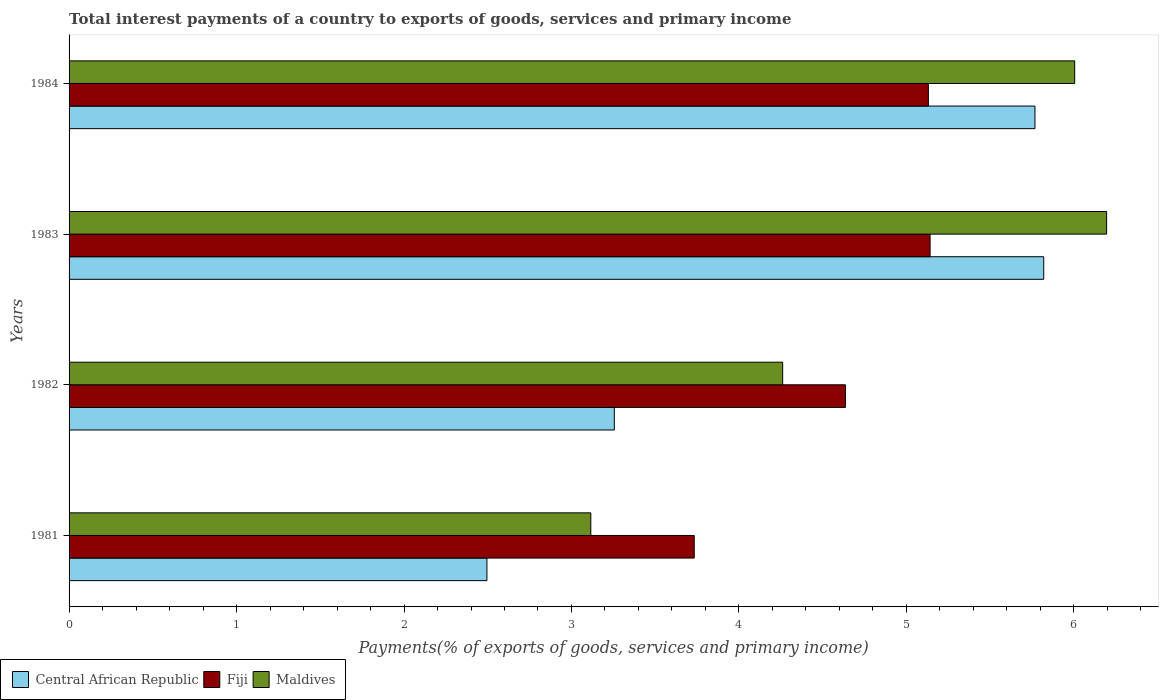How many different coloured bars are there?
Make the answer very short. 3. Are the number of bars per tick equal to the number of legend labels?
Give a very brief answer. Yes. How many bars are there on the 2nd tick from the bottom?
Your answer should be compact. 3. What is the label of the 1st group of bars from the top?
Your response must be concise. 1984. What is the total interest payments in Central African Republic in 1984?
Offer a terse response. 5.77. Across all years, what is the maximum total interest payments in Fiji?
Your answer should be very brief. 5.14. Across all years, what is the minimum total interest payments in Maldives?
Offer a very short reply. 3.12. In which year was the total interest payments in Fiji maximum?
Your response must be concise. 1983. In which year was the total interest payments in Maldives minimum?
Your answer should be compact. 1981. What is the total total interest payments in Central African Republic in the graph?
Provide a succinct answer. 17.34. What is the difference between the total interest payments in Central African Republic in 1983 and that in 1984?
Offer a terse response. 0.05. What is the difference between the total interest payments in Maldives in 1981 and the total interest payments in Fiji in 1983?
Provide a short and direct response. -2.03. What is the average total interest payments in Maldives per year?
Your answer should be compact. 4.89. In the year 1983, what is the difference between the total interest payments in Maldives and total interest payments in Fiji?
Your response must be concise. 1.05. What is the ratio of the total interest payments in Central African Republic in 1981 to that in 1982?
Offer a terse response. 0.77. Is the total interest payments in Central African Republic in 1983 less than that in 1984?
Your answer should be compact. No. What is the difference between the highest and the second highest total interest payments in Central African Republic?
Your response must be concise. 0.05. What is the difference between the highest and the lowest total interest payments in Central African Republic?
Provide a short and direct response. 3.32. In how many years, is the total interest payments in Maldives greater than the average total interest payments in Maldives taken over all years?
Your response must be concise. 2. Is the sum of the total interest payments in Maldives in 1981 and 1983 greater than the maximum total interest payments in Central African Republic across all years?
Your response must be concise. Yes. What does the 2nd bar from the top in 1984 represents?
Keep it short and to the point. Fiji. What does the 3rd bar from the bottom in 1981 represents?
Ensure brevity in your answer.  Maldives. Is it the case that in every year, the sum of the total interest payments in Central African Republic and total interest payments in Fiji is greater than the total interest payments in Maldives?
Your answer should be very brief. Yes. Does the graph contain grids?
Keep it short and to the point. No. Where does the legend appear in the graph?
Ensure brevity in your answer.  Bottom left. How many legend labels are there?
Your response must be concise. 3. What is the title of the graph?
Make the answer very short. Total interest payments of a country to exports of goods, services and primary income. What is the label or title of the X-axis?
Offer a terse response. Payments(% of exports of goods, services and primary income). What is the label or title of the Y-axis?
Provide a short and direct response. Years. What is the Payments(% of exports of goods, services and primary income) of Central African Republic in 1981?
Offer a very short reply. 2.5. What is the Payments(% of exports of goods, services and primary income) in Fiji in 1981?
Your answer should be compact. 3.73. What is the Payments(% of exports of goods, services and primary income) of Maldives in 1981?
Make the answer very short. 3.12. What is the Payments(% of exports of goods, services and primary income) of Central African Republic in 1982?
Your response must be concise. 3.26. What is the Payments(% of exports of goods, services and primary income) of Fiji in 1982?
Your answer should be compact. 4.64. What is the Payments(% of exports of goods, services and primary income) in Maldives in 1982?
Give a very brief answer. 4.26. What is the Payments(% of exports of goods, services and primary income) of Central African Republic in 1983?
Offer a terse response. 5.82. What is the Payments(% of exports of goods, services and primary income) of Fiji in 1983?
Offer a terse response. 5.14. What is the Payments(% of exports of goods, services and primary income) in Maldives in 1983?
Give a very brief answer. 6.2. What is the Payments(% of exports of goods, services and primary income) of Central African Republic in 1984?
Provide a succinct answer. 5.77. What is the Payments(% of exports of goods, services and primary income) of Fiji in 1984?
Ensure brevity in your answer.  5.13. What is the Payments(% of exports of goods, services and primary income) in Maldives in 1984?
Offer a terse response. 6. Across all years, what is the maximum Payments(% of exports of goods, services and primary income) of Central African Republic?
Provide a succinct answer. 5.82. Across all years, what is the maximum Payments(% of exports of goods, services and primary income) of Fiji?
Your answer should be compact. 5.14. Across all years, what is the maximum Payments(% of exports of goods, services and primary income) of Maldives?
Provide a succinct answer. 6.2. Across all years, what is the minimum Payments(% of exports of goods, services and primary income) in Central African Republic?
Your response must be concise. 2.5. Across all years, what is the minimum Payments(% of exports of goods, services and primary income) in Fiji?
Make the answer very short. 3.73. Across all years, what is the minimum Payments(% of exports of goods, services and primary income) of Maldives?
Make the answer very short. 3.12. What is the total Payments(% of exports of goods, services and primary income) of Central African Republic in the graph?
Ensure brevity in your answer.  17.34. What is the total Payments(% of exports of goods, services and primary income) of Fiji in the graph?
Your response must be concise. 18.64. What is the total Payments(% of exports of goods, services and primary income) of Maldives in the graph?
Offer a very short reply. 19.58. What is the difference between the Payments(% of exports of goods, services and primary income) in Central African Republic in 1981 and that in 1982?
Your response must be concise. -0.76. What is the difference between the Payments(% of exports of goods, services and primary income) in Fiji in 1981 and that in 1982?
Make the answer very short. -0.9. What is the difference between the Payments(% of exports of goods, services and primary income) in Maldives in 1981 and that in 1982?
Provide a short and direct response. -1.15. What is the difference between the Payments(% of exports of goods, services and primary income) in Central African Republic in 1981 and that in 1983?
Provide a short and direct response. -3.32. What is the difference between the Payments(% of exports of goods, services and primary income) in Fiji in 1981 and that in 1983?
Your response must be concise. -1.41. What is the difference between the Payments(% of exports of goods, services and primary income) of Maldives in 1981 and that in 1983?
Provide a short and direct response. -3.08. What is the difference between the Payments(% of exports of goods, services and primary income) in Central African Republic in 1981 and that in 1984?
Provide a succinct answer. -3.27. What is the difference between the Payments(% of exports of goods, services and primary income) in Fiji in 1981 and that in 1984?
Offer a very short reply. -1.4. What is the difference between the Payments(% of exports of goods, services and primary income) of Maldives in 1981 and that in 1984?
Your response must be concise. -2.89. What is the difference between the Payments(% of exports of goods, services and primary income) of Central African Republic in 1982 and that in 1983?
Your answer should be very brief. -2.56. What is the difference between the Payments(% of exports of goods, services and primary income) in Fiji in 1982 and that in 1983?
Give a very brief answer. -0.51. What is the difference between the Payments(% of exports of goods, services and primary income) of Maldives in 1982 and that in 1983?
Give a very brief answer. -1.93. What is the difference between the Payments(% of exports of goods, services and primary income) of Central African Republic in 1982 and that in 1984?
Your response must be concise. -2.51. What is the difference between the Payments(% of exports of goods, services and primary income) of Fiji in 1982 and that in 1984?
Ensure brevity in your answer.  -0.5. What is the difference between the Payments(% of exports of goods, services and primary income) of Maldives in 1982 and that in 1984?
Ensure brevity in your answer.  -1.74. What is the difference between the Payments(% of exports of goods, services and primary income) of Central African Republic in 1983 and that in 1984?
Ensure brevity in your answer.  0.05. What is the difference between the Payments(% of exports of goods, services and primary income) in Fiji in 1983 and that in 1984?
Your answer should be very brief. 0.01. What is the difference between the Payments(% of exports of goods, services and primary income) in Maldives in 1983 and that in 1984?
Offer a terse response. 0.19. What is the difference between the Payments(% of exports of goods, services and primary income) of Central African Republic in 1981 and the Payments(% of exports of goods, services and primary income) of Fiji in 1982?
Make the answer very short. -2.14. What is the difference between the Payments(% of exports of goods, services and primary income) of Central African Republic in 1981 and the Payments(% of exports of goods, services and primary income) of Maldives in 1982?
Provide a succinct answer. -1.77. What is the difference between the Payments(% of exports of goods, services and primary income) of Fiji in 1981 and the Payments(% of exports of goods, services and primary income) of Maldives in 1982?
Ensure brevity in your answer.  -0.53. What is the difference between the Payments(% of exports of goods, services and primary income) of Central African Republic in 1981 and the Payments(% of exports of goods, services and primary income) of Fiji in 1983?
Keep it short and to the point. -2.65. What is the difference between the Payments(% of exports of goods, services and primary income) of Central African Republic in 1981 and the Payments(% of exports of goods, services and primary income) of Maldives in 1983?
Offer a very short reply. -3.7. What is the difference between the Payments(% of exports of goods, services and primary income) in Fiji in 1981 and the Payments(% of exports of goods, services and primary income) in Maldives in 1983?
Give a very brief answer. -2.46. What is the difference between the Payments(% of exports of goods, services and primary income) of Central African Republic in 1981 and the Payments(% of exports of goods, services and primary income) of Fiji in 1984?
Offer a very short reply. -2.64. What is the difference between the Payments(% of exports of goods, services and primary income) of Central African Republic in 1981 and the Payments(% of exports of goods, services and primary income) of Maldives in 1984?
Your answer should be compact. -3.51. What is the difference between the Payments(% of exports of goods, services and primary income) in Fiji in 1981 and the Payments(% of exports of goods, services and primary income) in Maldives in 1984?
Ensure brevity in your answer.  -2.27. What is the difference between the Payments(% of exports of goods, services and primary income) of Central African Republic in 1982 and the Payments(% of exports of goods, services and primary income) of Fiji in 1983?
Make the answer very short. -1.89. What is the difference between the Payments(% of exports of goods, services and primary income) of Central African Republic in 1982 and the Payments(% of exports of goods, services and primary income) of Maldives in 1983?
Ensure brevity in your answer.  -2.94. What is the difference between the Payments(% of exports of goods, services and primary income) of Fiji in 1982 and the Payments(% of exports of goods, services and primary income) of Maldives in 1983?
Offer a terse response. -1.56. What is the difference between the Payments(% of exports of goods, services and primary income) of Central African Republic in 1982 and the Payments(% of exports of goods, services and primary income) of Fiji in 1984?
Provide a short and direct response. -1.88. What is the difference between the Payments(% of exports of goods, services and primary income) of Central African Republic in 1982 and the Payments(% of exports of goods, services and primary income) of Maldives in 1984?
Your answer should be very brief. -2.75. What is the difference between the Payments(% of exports of goods, services and primary income) in Fiji in 1982 and the Payments(% of exports of goods, services and primary income) in Maldives in 1984?
Ensure brevity in your answer.  -1.37. What is the difference between the Payments(% of exports of goods, services and primary income) in Central African Republic in 1983 and the Payments(% of exports of goods, services and primary income) in Fiji in 1984?
Offer a terse response. 0.69. What is the difference between the Payments(% of exports of goods, services and primary income) in Central African Republic in 1983 and the Payments(% of exports of goods, services and primary income) in Maldives in 1984?
Your answer should be very brief. -0.18. What is the difference between the Payments(% of exports of goods, services and primary income) of Fiji in 1983 and the Payments(% of exports of goods, services and primary income) of Maldives in 1984?
Your answer should be very brief. -0.86. What is the average Payments(% of exports of goods, services and primary income) of Central African Republic per year?
Your response must be concise. 4.33. What is the average Payments(% of exports of goods, services and primary income) of Fiji per year?
Keep it short and to the point. 4.66. What is the average Payments(% of exports of goods, services and primary income) of Maldives per year?
Provide a succinct answer. 4.89. In the year 1981, what is the difference between the Payments(% of exports of goods, services and primary income) of Central African Republic and Payments(% of exports of goods, services and primary income) of Fiji?
Offer a terse response. -1.24. In the year 1981, what is the difference between the Payments(% of exports of goods, services and primary income) of Central African Republic and Payments(% of exports of goods, services and primary income) of Maldives?
Make the answer very short. -0.62. In the year 1981, what is the difference between the Payments(% of exports of goods, services and primary income) in Fiji and Payments(% of exports of goods, services and primary income) in Maldives?
Offer a very short reply. 0.62. In the year 1982, what is the difference between the Payments(% of exports of goods, services and primary income) of Central African Republic and Payments(% of exports of goods, services and primary income) of Fiji?
Offer a terse response. -1.38. In the year 1982, what is the difference between the Payments(% of exports of goods, services and primary income) of Central African Republic and Payments(% of exports of goods, services and primary income) of Maldives?
Give a very brief answer. -1.01. In the year 1982, what is the difference between the Payments(% of exports of goods, services and primary income) in Fiji and Payments(% of exports of goods, services and primary income) in Maldives?
Give a very brief answer. 0.37. In the year 1983, what is the difference between the Payments(% of exports of goods, services and primary income) of Central African Republic and Payments(% of exports of goods, services and primary income) of Fiji?
Give a very brief answer. 0.68. In the year 1983, what is the difference between the Payments(% of exports of goods, services and primary income) in Central African Republic and Payments(% of exports of goods, services and primary income) in Maldives?
Your response must be concise. -0.38. In the year 1983, what is the difference between the Payments(% of exports of goods, services and primary income) of Fiji and Payments(% of exports of goods, services and primary income) of Maldives?
Provide a succinct answer. -1.05. In the year 1984, what is the difference between the Payments(% of exports of goods, services and primary income) of Central African Republic and Payments(% of exports of goods, services and primary income) of Fiji?
Your response must be concise. 0.64. In the year 1984, what is the difference between the Payments(% of exports of goods, services and primary income) of Central African Republic and Payments(% of exports of goods, services and primary income) of Maldives?
Your answer should be compact. -0.24. In the year 1984, what is the difference between the Payments(% of exports of goods, services and primary income) of Fiji and Payments(% of exports of goods, services and primary income) of Maldives?
Make the answer very short. -0.87. What is the ratio of the Payments(% of exports of goods, services and primary income) of Central African Republic in 1981 to that in 1982?
Keep it short and to the point. 0.77. What is the ratio of the Payments(% of exports of goods, services and primary income) of Fiji in 1981 to that in 1982?
Provide a succinct answer. 0.81. What is the ratio of the Payments(% of exports of goods, services and primary income) of Maldives in 1981 to that in 1982?
Your response must be concise. 0.73. What is the ratio of the Payments(% of exports of goods, services and primary income) of Central African Republic in 1981 to that in 1983?
Ensure brevity in your answer.  0.43. What is the ratio of the Payments(% of exports of goods, services and primary income) of Fiji in 1981 to that in 1983?
Your answer should be compact. 0.73. What is the ratio of the Payments(% of exports of goods, services and primary income) in Maldives in 1981 to that in 1983?
Provide a short and direct response. 0.5. What is the ratio of the Payments(% of exports of goods, services and primary income) in Central African Republic in 1981 to that in 1984?
Offer a very short reply. 0.43. What is the ratio of the Payments(% of exports of goods, services and primary income) of Fiji in 1981 to that in 1984?
Offer a very short reply. 0.73. What is the ratio of the Payments(% of exports of goods, services and primary income) of Maldives in 1981 to that in 1984?
Offer a very short reply. 0.52. What is the ratio of the Payments(% of exports of goods, services and primary income) of Central African Republic in 1982 to that in 1983?
Keep it short and to the point. 0.56. What is the ratio of the Payments(% of exports of goods, services and primary income) of Fiji in 1982 to that in 1983?
Your response must be concise. 0.9. What is the ratio of the Payments(% of exports of goods, services and primary income) of Maldives in 1982 to that in 1983?
Ensure brevity in your answer.  0.69. What is the ratio of the Payments(% of exports of goods, services and primary income) in Central African Republic in 1982 to that in 1984?
Make the answer very short. 0.56. What is the ratio of the Payments(% of exports of goods, services and primary income) of Fiji in 1982 to that in 1984?
Provide a succinct answer. 0.9. What is the ratio of the Payments(% of exports of goods, services and primary income) in Maldives in 1982 to that in 1984?
Provide a short and direct response. 0.71. What is the ratio of the Payments(% of exports of goods, services and primary income) in Central African Republic in 1983 to that in 1984?
Keep it short and to the point. 1.01. What is the ratio of the Payments(% of exports of goods, services and primary income) in Fiji in 1983 to that in 1984?
Offer a terse response. 1. What is the ratio of the Payments(% of exports of goods, services and primary income) of Maldives in 1983 to that in 1984?
Offer a terse response. 1.03. What is the difference between the highest and the second highest Payments(% of exports of goods, services and primary income) in Central African Republic?
Provide a short and direct response. 0.05. What is the difference between the highest and the second highest Payments(% of exports of goods, services and primary income) of Fiji?
Your response must be concise. 0.01. What is the difference between the highest and the second highest Payments(% of exports of goods, services and primary income) of Maldives?
Make the answer very short. 0.19. What is the difference between the highest and the lowest Payments(% of exports of goods, services and primary income) of Central African Republic?
Your answer should be compact. 3.32. What is the difference between the highest and the lowest Payments(% of exports of goods, services and primary income) of Fiji?
Your response must be concise. 1.41. What is the difference between the highest and the lowest Payments(% of exports of goods, services and primary income) in Maldives?
Ensure brevity in your answer.  3.08. 